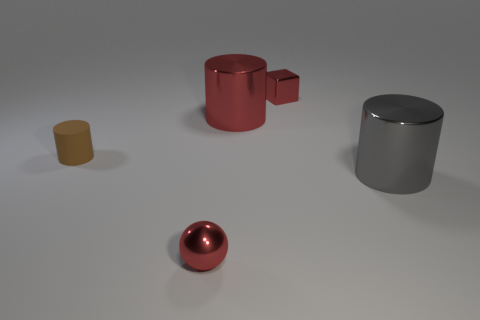The tiny rubber thing that is the same shape as the large gray thing is what color?
Ensure brevity in your answer.  Brown. How many yellow blocks are made of the same material as the tiny ball?
Your answer should be compact. 0. There is a shiny object that is left of the large red shiny thing; is its size the same as the gray object in front of the small rubber cylinder?
Keep it short and to the point. No. The big object that is to the right of the tiny metal object behind the shiny cylinder that is on the right side of the red block is what color?
Provide a succinct answer. Gray. Are there any green things that have the same shape as the small brown thing?
Your answer should be very brief. No. Are there the same number of metallic cylinders on the left side of the big gray object and rubber objects in front of the brown rubber thing?
Keep it short and to the point. No. Is the shape of the big object that is behind the large gray metal cylinder the same as  the big gray metal thing?
Ensure brevity in your answer.  Yes. Is the gray shiny thing the same shape as the small rubber object?
Your response must be concise. Yes. What number of rubber things are either large purple cylinders or big objects?
Keep it short and to the point. 0. There is a big cylinder that is the same color as the small metal cube; what is it made of?
Keep it short and to the point. Metal. 